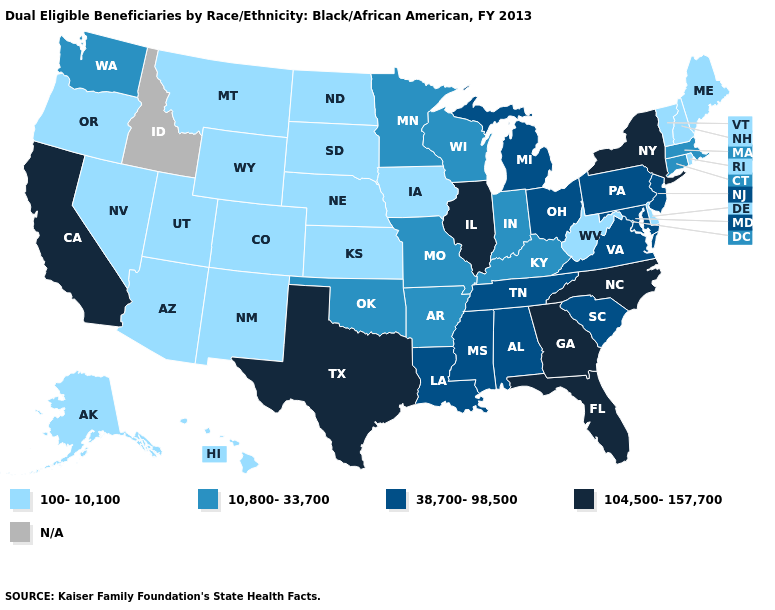Among the states that border Arkansas , which have the highest value?
Concise answer only. Texas. Name the states that have a value in the range 38,700-98,500?
Quick response, please. Alabama, Louisiana, Maryland, Michigan, Mississippi, New Jersey, Ohio, Pennsylvania, South Carolina, Tennessee, Virginia. What is the value of Colorado?
Concise answer only. 100-10,100. Name the states that have a value in the range 10,800-33,700?
Answer briefly. Arkansas, Connecticut, Indiana, Kentucky, Massachusetts, Minnesota, Missouri, Oklahoma, Washington, Wisconsin. What is the highest value in the South ?
Be succinct. 104,500-157,700. Name the states that have a value in the range 100-10,100?
Short answer required. Alaska, Arizona, Colorado, Delaware, Hawaii, Iowa, Kansas, Maine, Montana, Nebraska, Nevada, New Hampshire, New Mexico, North Dakota, Oregon, Rhode Island, South Dakota, Utah, Vermont, West Virginia, Wyoming. How many symbols are there in the legend?
Quick response, please. 5. Name the states that have a value in the range 38,700-98,500?
Write a very short answer. Alabama, Louisiana, Maryland, Michigan, Mississippi, New Jersey, Ohio, Pennsylvania, South Carolina, Tennessee, Virginia. Name the states that have a value in the range 100-10,100?
Give a very brief answer. Alaska, Arizona, Colorado, Delaware, Hawaii, Iowa, Kansas, Maine, Montana, Nebraska, Nevada, New Hampshire, New Mexico, North Dakota, Oregon, Rhode Island, South Dakota, Utah, Vermont, West Virginia, Wyoming. Name the states that have a value in the range 38,700-98,500?
Write a very short answer. Alabama, Louisiana, Maryland, Michigan, Mississippi, New Jersey, Ohio, Pennsylvania, South Carolina, Tennessee, Virginia. Name the states that have a value in the range 10,800-33,700?
Be succinct. Arkansas, Connecticut, Indiana, Kentucky, Massachusetts, Minnesota, Missouri, Oklahoma, Washington, Wisconsin. What is the value of Vermont?
Quick response, please. 100-10,100. Which states have the lowest value in the South?
Quick response, please. Delaware, West Virginia. 